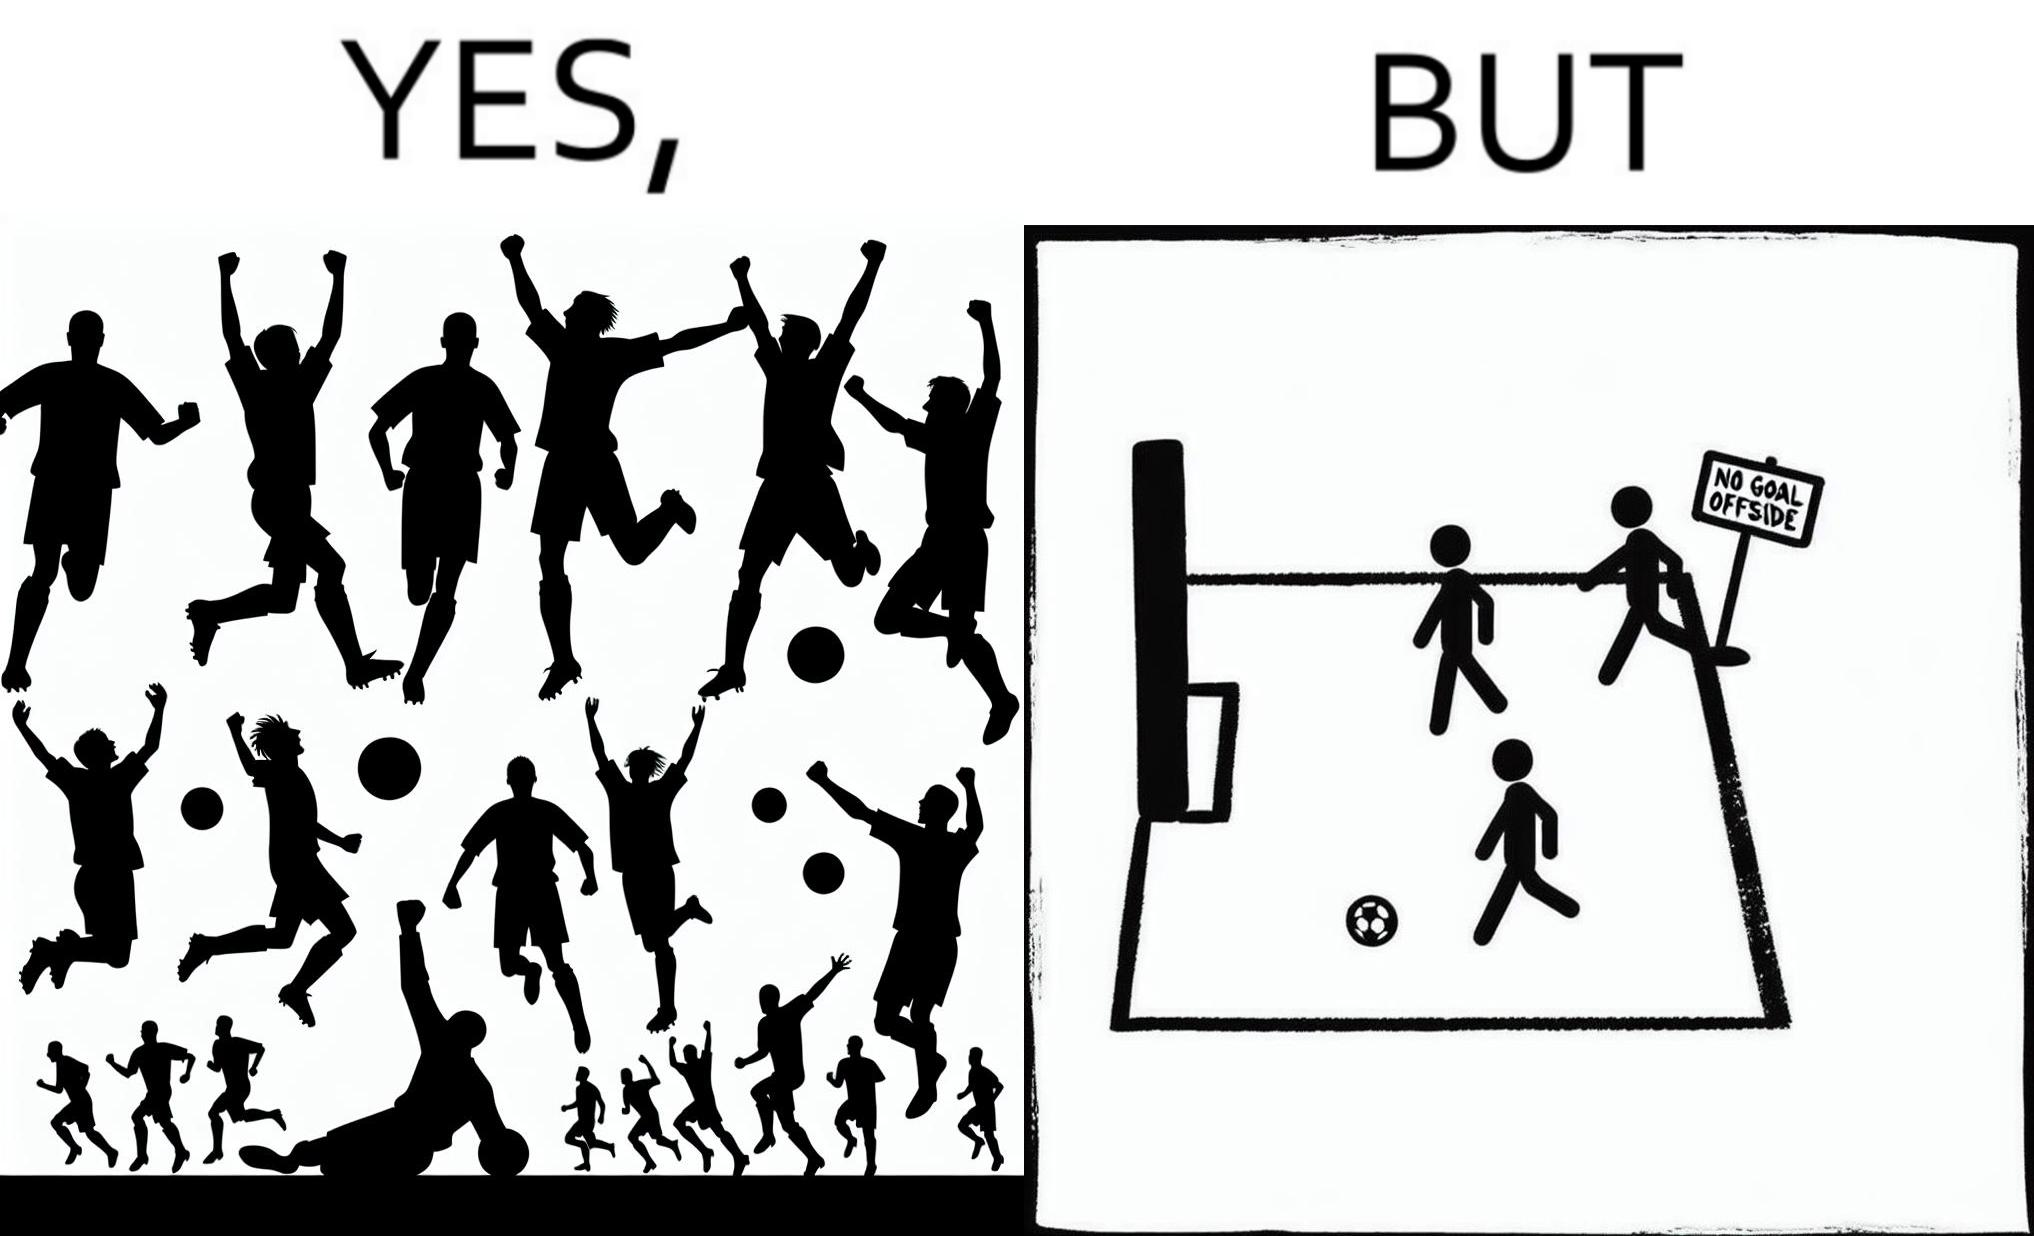Explain why this image is satirical. The image is ironical, as the team is celebrating as they think that they have scored a goal, but the sign on the screen says that it is an offside, and not a goal. This is a very common scenario in football matches. 